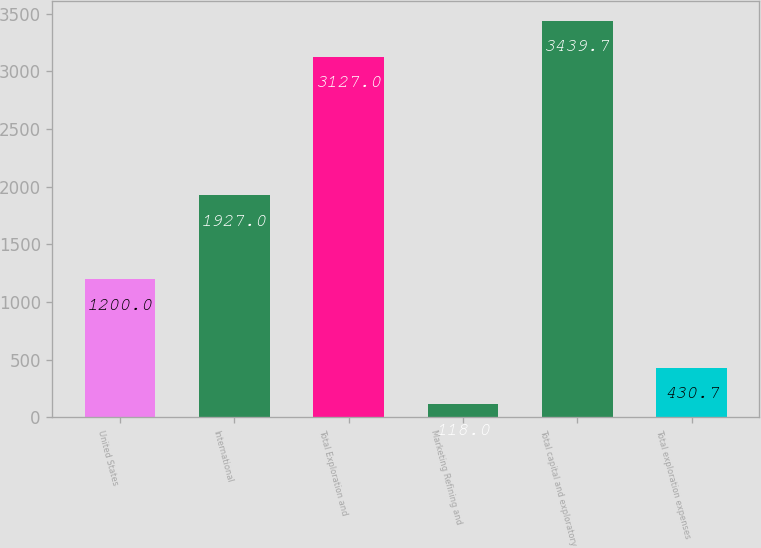Convert chart to OTSL. <chart><loc_0><loc_0><loc_500><loc_500><bar_chart><fcel>United States<fcel>International<fcel>Total Exploration and<fcel>Marketing Refining and<fcel>Total capital and exploratory<fcel>Total exploration expenses<nl><fcel>1200<fcel>1927<fcel>3127<fcel>118<fcel>3439.7<fcel>430.7<nl></chart> 